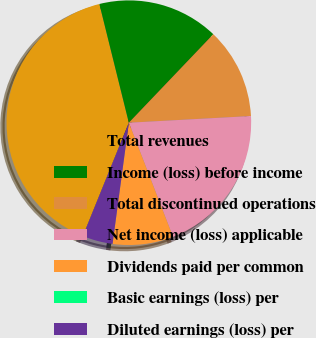Convert chart. <chart><loc_0><loc_0><loc_500><loc_500><pie_chart><fcel>Total revenues<fcel>Income (loss) before income<fcel>Total discontinued operations<fcel>Net income (loss) applicable<fcel>Dividends paid per common<fcel>Basic earnings (loss) per<fcel>Diluted earnings (loss) per<nl><fcel>40.0%<fcel>16.0%<fcel>12.0%<fcel>20.0%<fcel>8.0%<fcel>0.0%<fcel>4.0%<nl></chart> 